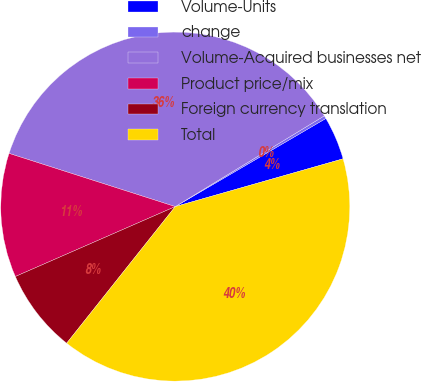Convert chart. <chart><loc_0><loc_0><loc_500><loc_500><pie_chart><fcel>Volume-Units<fcel>change<fcel>Volume-Acquired businesses net<fcel>Product price/mix<fcel>Foreign currency translation<fcel>Total<nl><fcel>4.01%<fcel>0.28%<fcel>36.36%<fcel>11.49%<fcel>7.75%<fcel>40.1%<nl></chart> 